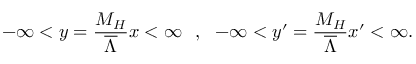Convert formula to latex. <formula><loc_0><loc_0><loc_500><loc_500>- \infty < y = { \frac { M _ { H } } { \overline { \Lambda } } } x < \infty , - \infty < y ^ { \prime } = { \frac { M _ { H } } { \overline { \Lambda } } } x ^ { \prime } < \infty .</formula> 